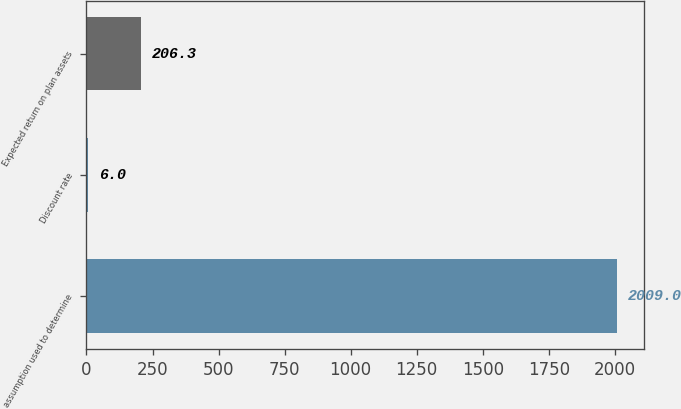Convert chart to OTSL. <chart><loc_0><loc_0><loc_500><loc_500><bar_chart><fcel>assumption used to determine<fcel>Discount rate<fcel>Expected return on plan assets<nl><fcel>2009<fcel>6<fcel>206.3<nl></chart> 